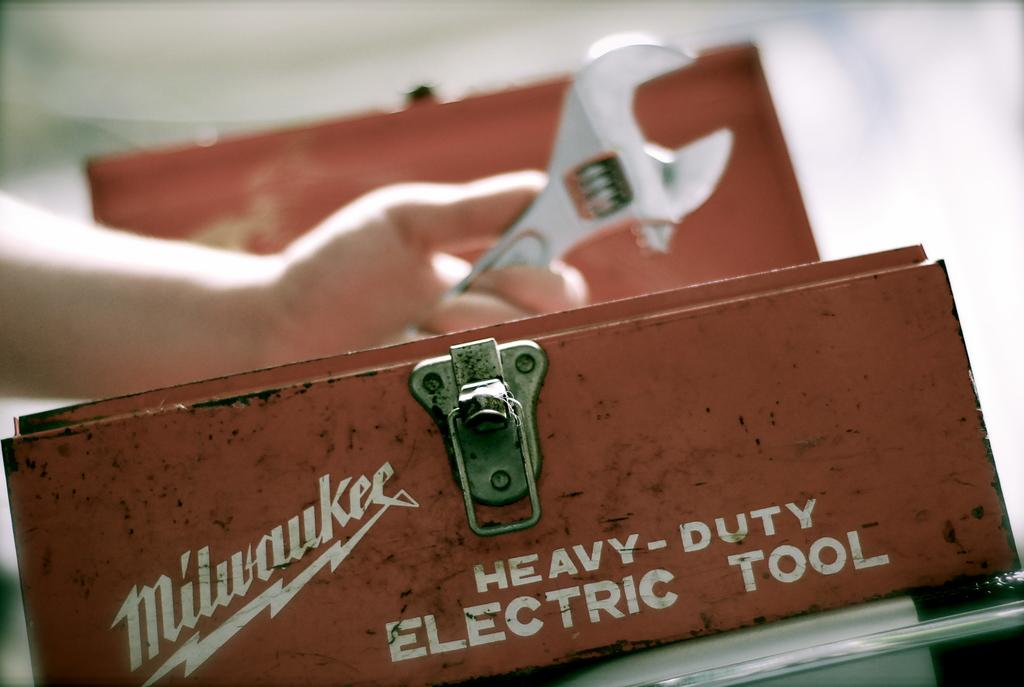What is the main subject of the image? There is a person in the image. What is the person holding in the image? The person is holding a spanner. What else can be seen in the image besides the person? There is a box in the image. Can you describe the background of the image? The background of the image is blurred. What type of pollution can be seen in the image? There is no pollution visible in the image. How many passengers are present in the image? A: There is only one person present in the image, so there is no passenger. 